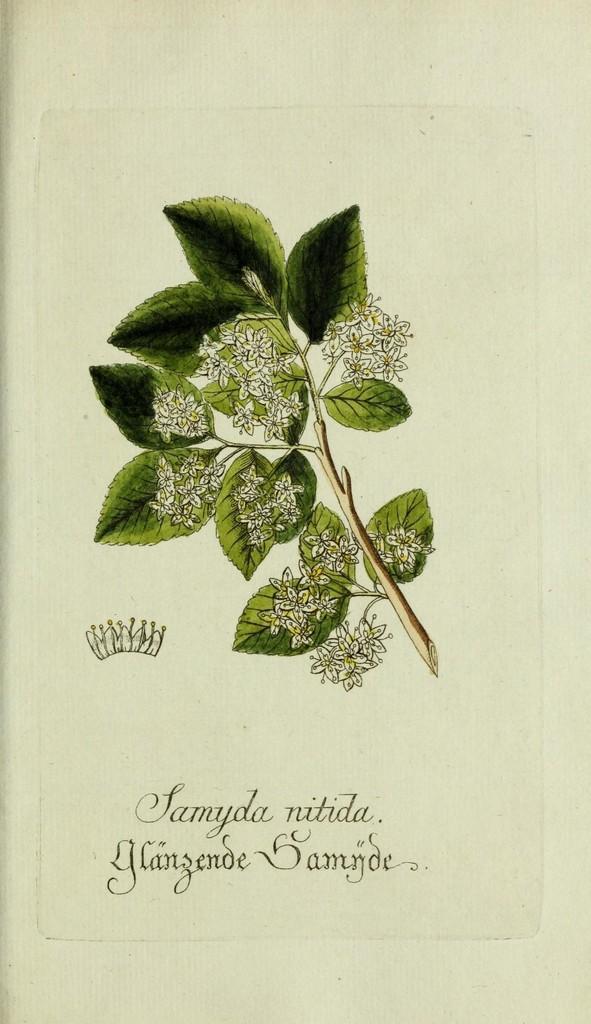Can you describe this image briefly? In this picture there is a sketch of flowers and leaves. At the bottom, there is a text. 